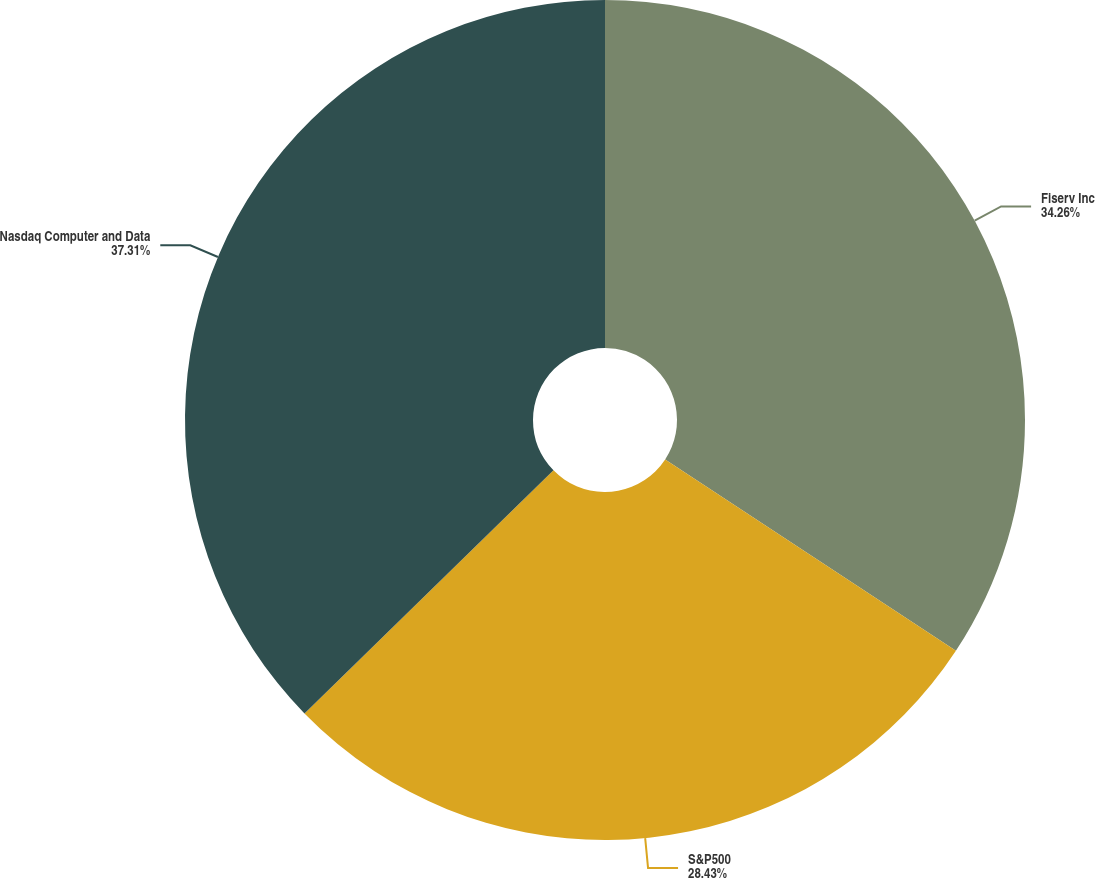Convert chart to OTSL. <chart><loc_0><loc_0><loc_500><loc_500><pie_chart><fcel>Fiserv Inc<fcel>S&P500<fcel>Nasdaq Computer and Data<nl><fcel>34.26%<fcel>28.43%<fcel>37.31%<nl></chart> 